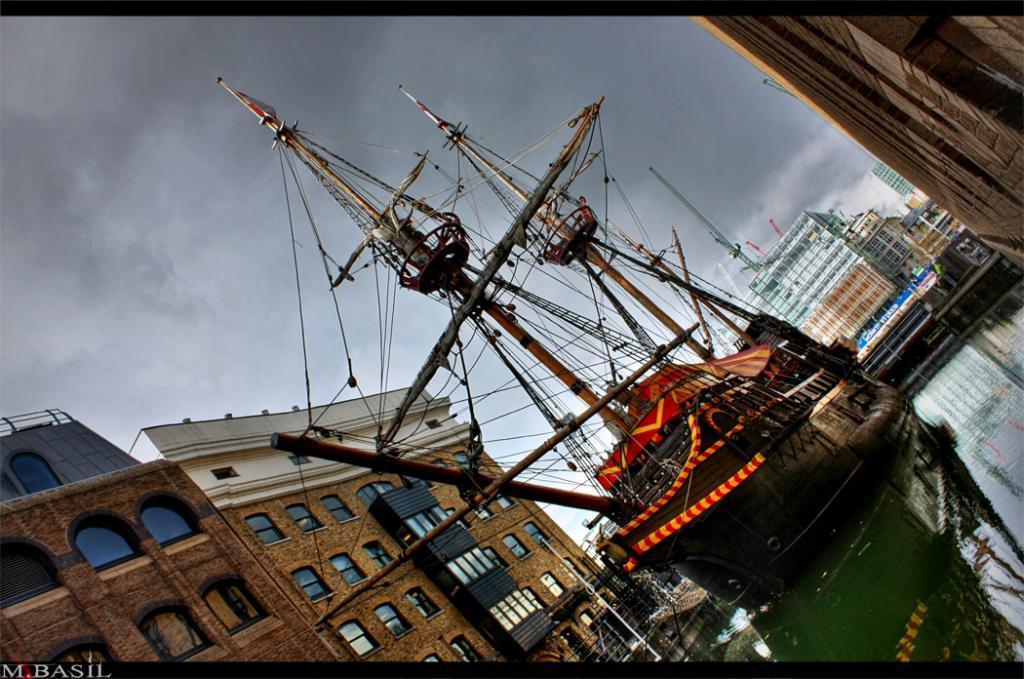Please provide a concise description of this image. In the center of the image there is a ship on the water. On the right side of the image there is a building. On the left side of the image we can see poles and buildings. In the background there are buildings, sky and clouds. 